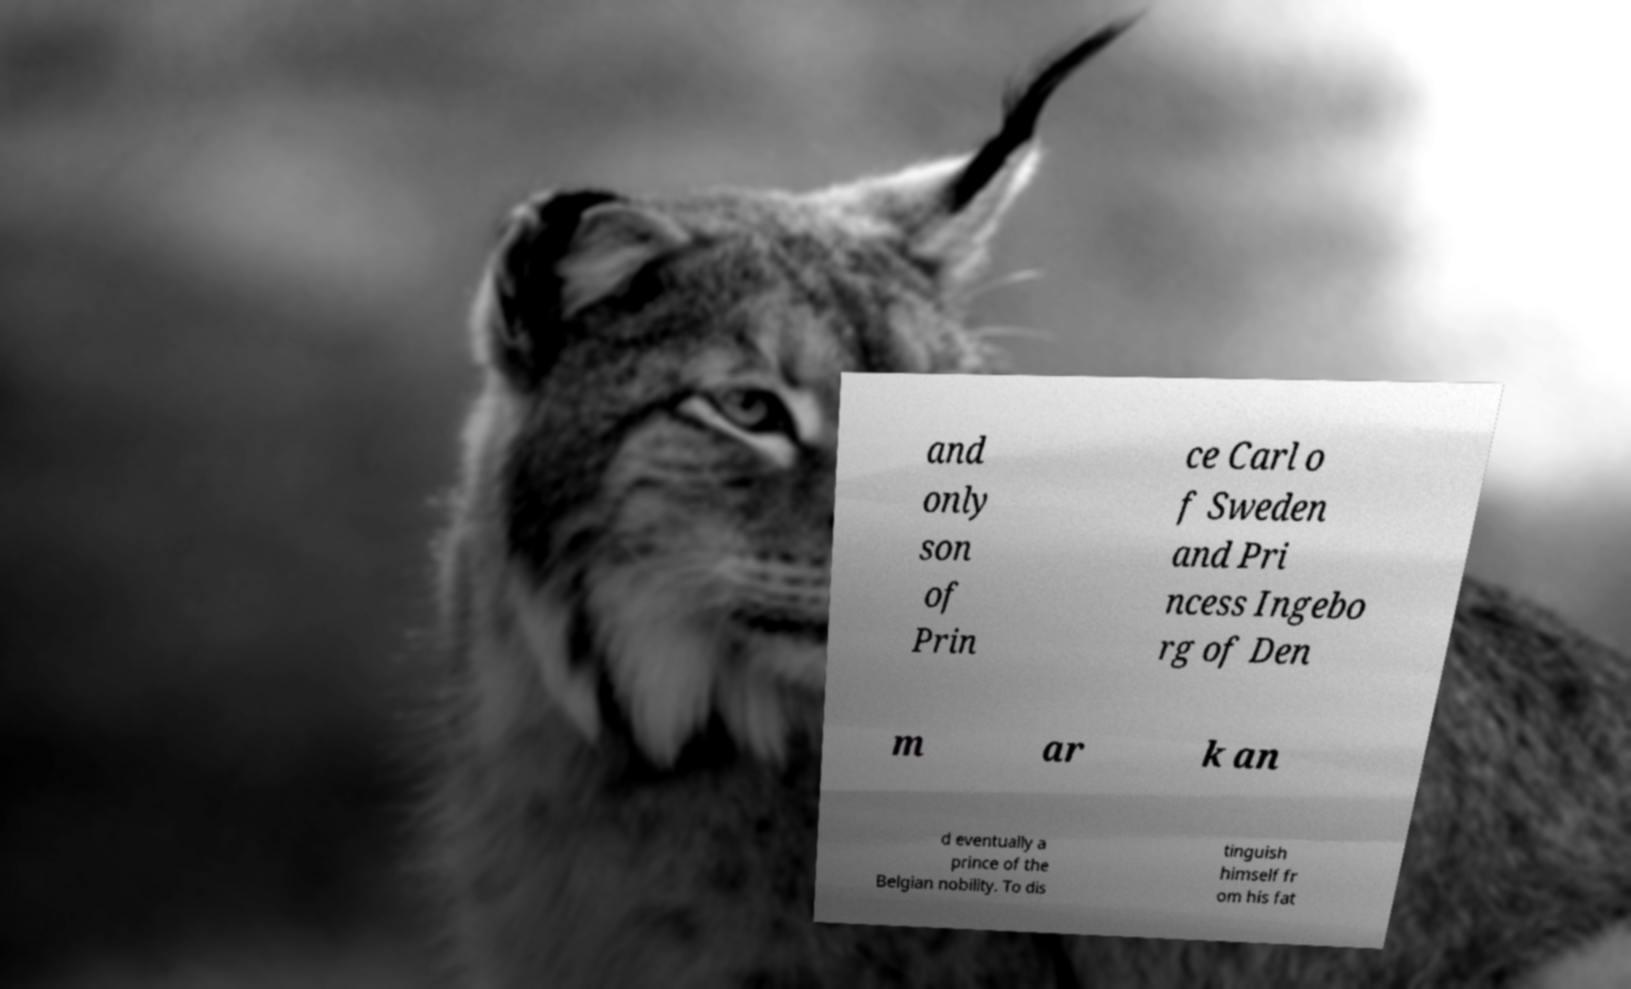Can you accurately transcribe the text from the provided image for me? and only son of Prin ce Carl o f Sweden and Pri ncess Ingebo rg of Den m ar k an d eventually a prince of the Belgian nobility. To dis tinguish himself fr om his fat 